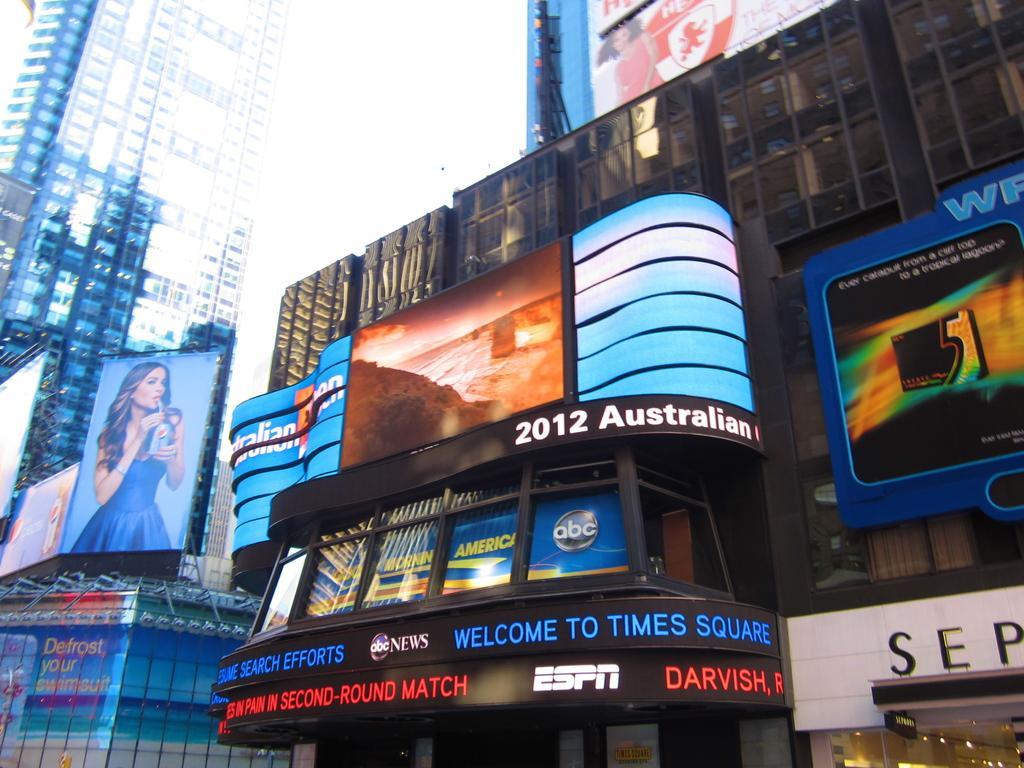Describe this image in one or two sentences. This image is taken outdoors. In the middle of the image there are two buildings with walls, windows, roofs and doors and there are many boards with text on them. There are a few lights and there are a few posts. 